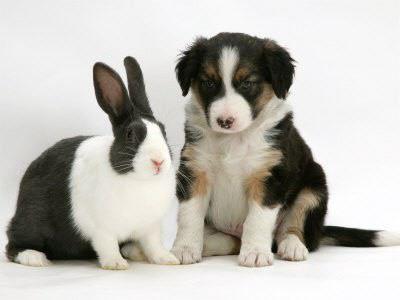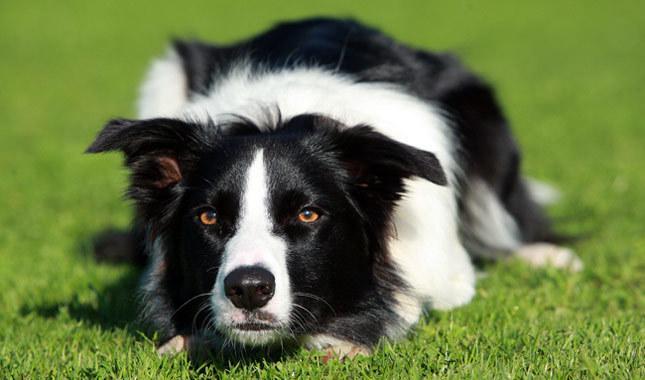The first image is the image on the left, the second image is the image on the right. Given the left and right images, does the statement "One image shows two animals side-by-side with a plain backdrop." hold true? Answer yes or no. Yes. The first image is the image on the left, the second image is the image on the right. For the images shown, is this caption "There are two animals" true? Answer yes or no. No. 